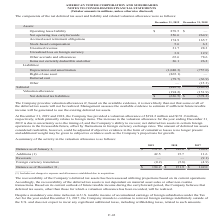From American Tower Corporation's financial document, In which years did the company provide a valuation allowance? The document shows two values: 2019 and 2018. From the document: "2019 2018 2017 2019 2018 2017..." Also, What was the valuation allowance provided by the company in 2018 and 2019 respectively? The document shows two values: $151.9 million and $194.2 million. From the document: "the Company has provided a valuation allowance of $194.2 million and $151.9 million, respectively, which primarily relates to foreign items. The incre..." Also, What were the additions in 2019? According to the financial document, 42.5 (in millions). The relevant text states: "Additions (1) 42.5 15.7 11.6..." Also, How many years was the balance as of January 1 above $100 million? Counting the relevant items in the document: 2019, 2018, 2017, I find 3 instances. The key data points involved are: 2017, 2018, 2019. Also, How many years was the balance as of December 31 above $150 million? Counting the relevant items in the document: 2019, 2018, I find 2 instances. The key data points involved are: 2018, 2019. Also, can you calculate: What was the percentage change in Foreign currency translation between 2018 and 2019? To answer this question, I need to perform calculations using the financial data. The calculation is: (-0.2-(-5.8))/-5.8, which equals -96.55 (percentage). This is based on the information: "Foreign currency translation (0.2) (5.8) (4.9) Foreign currency translation (0.2) (5.8) (4.9)..." The key data points involved are: 0.2, 5.8. 